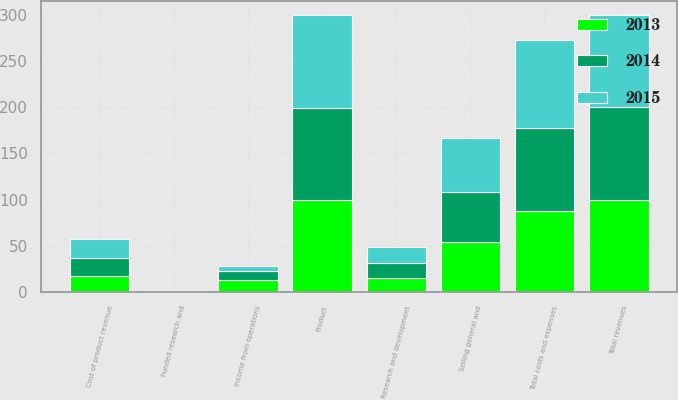Convert chart to OTSL. <chart><loc_0><loc_0><loc_500><loc_500><stacked_bar_chart><ecel><fcel>Product<fcel>Funded research and<fcel>Total revenues<fcel>Cost of product revenue<fcel>Research and development<fcel>Selling general and<fcel>Total costs and expenses<fcel>Income from operations<nl><fcel>2013<fcel>99.8<fcel>0.2<fcel>100<fcel>17.3<fcel>15.6<fcel>54.6<fcel>87.5<fcel>12.5<nl><fcel>2015<fcel>99.8<fcel>0.2<fcel>100<fcel>20.3<fcel>16.7<fcel>58.4<fcel>95.4<fcel>4.6<nl><fcel>2014<fcel>99.7<fcel>0.3<fcel>100<fcel>20<fcel>16.2<fcel>53.3<fcel>89.5<fcel>10.5<nl></chart> 